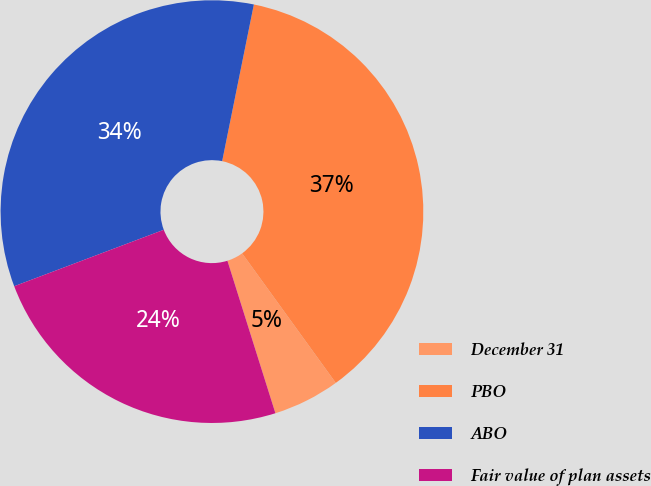<chart> <loc_0><loc_0><loc_500><loc_500><pie_chart><fcel>December 31<fcel>PBO<fcel>ABO<fcel>Fair value of plan assets<nl><fcel>5.11%<fcel>36.86%<fcel>33.92%<fcel>24.11%<nl></chart> 